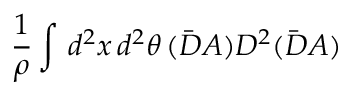<formula> <loc_0><loc_0><loc_500><loc_500>\frac { 1 } { \rho } \int \, d ^ { 2 } x \, d ^ { 2 } \theta \, ( \bar { D } A ) D ^ { 2 } ( \bar { D } A )</formula> 